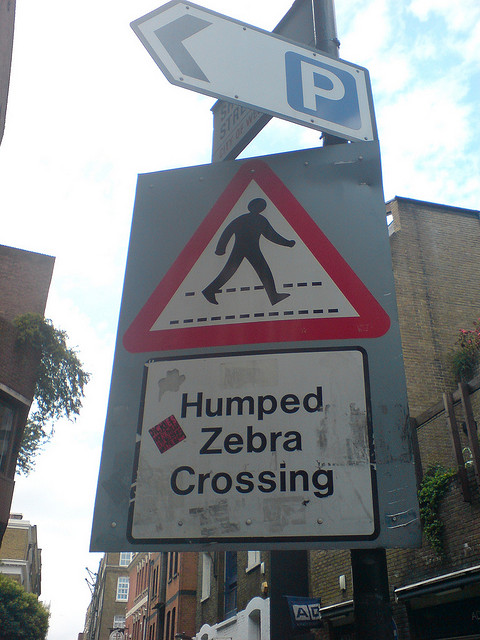<image>What does the bicycle sign say? I don't know what the bicycle sign says. It could possibly indicate 'humped zebra crossing' or 'parking to left'. Why is the bottom sign funny? It is ambiguous why the bottom sign is funny. It might possibly be due to the phrase 'humped zebra crossing'. What does the bicycle sign say? I am not sure what the bicycle sign says. It can be seen 'humped zebra crossing', 'nothing', 'crossing', 'parking to left' or 'no'. Why is the bottom sign funny? I don't know why the bottom sign is funny. It could be because of the innuendo or the reference to humped zebras crossing. 